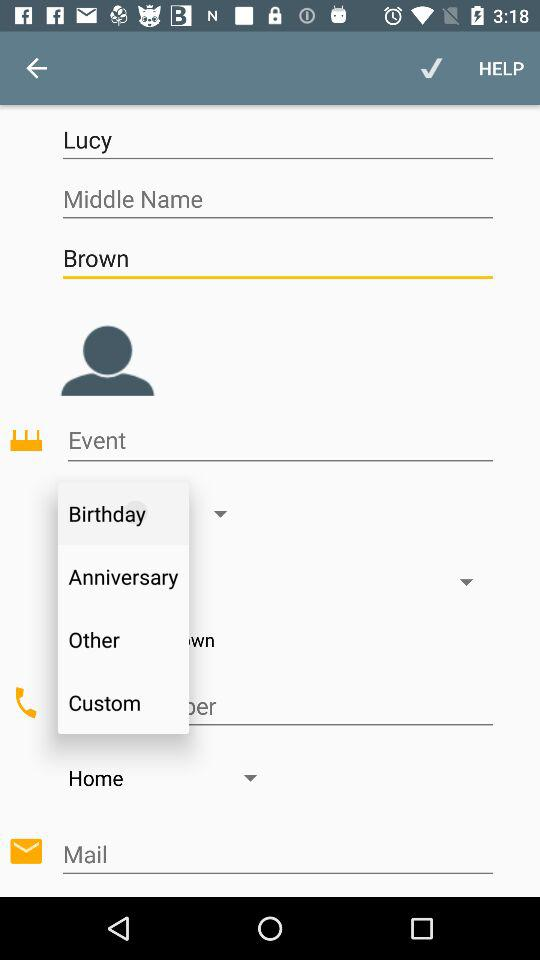What is the last name of the user? The last name of the user is Brown. 